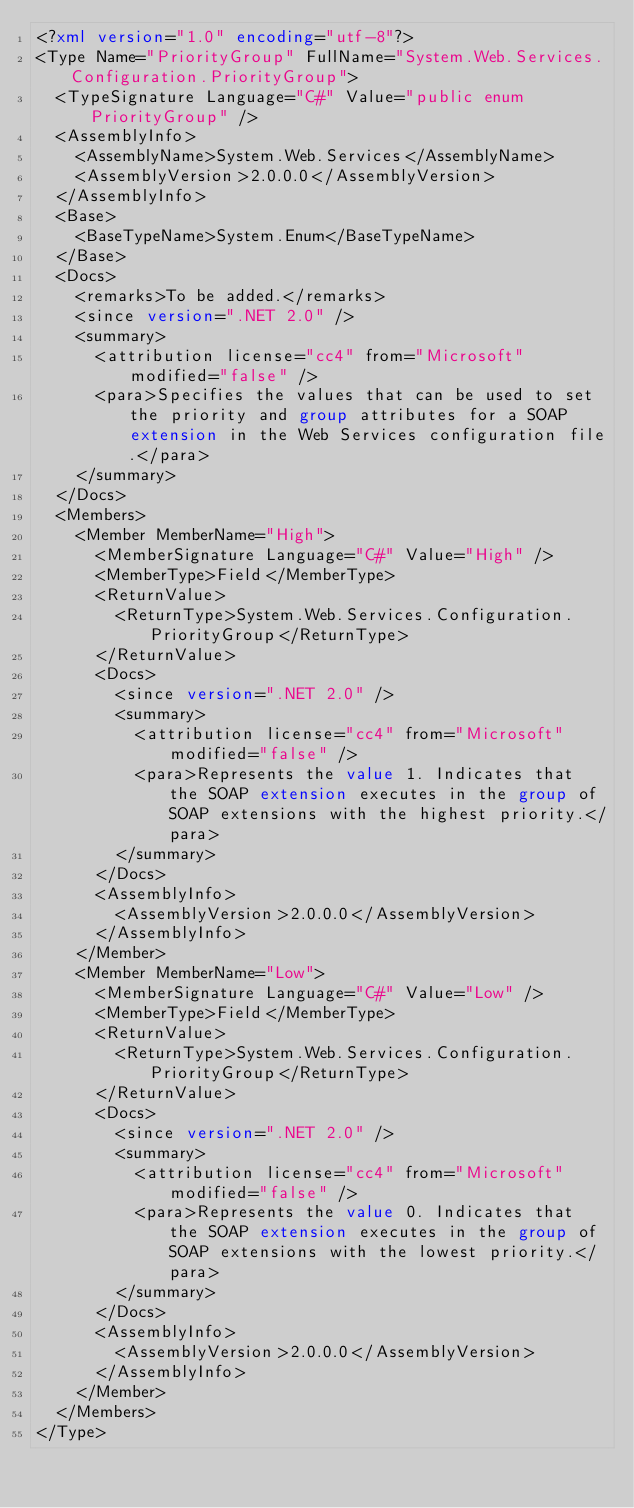Convert code to text. <code><loc_0><loc_0><loc_500><loc_500><_XML_><?xml version="1.0" encoding="utf-8"?>
<Type Name="PriorityGroup" FullName="System.Web.Services.Configuration.PriorityGroup">
  <TypeSignature Language="C#" Value="public enum PriorityGroup" />
  <AssemblyInfo>
    <AssemblyName>System.Web.Services</AssemblyName>
    <AssemblyVersion>2.0.0.0</AssemblyVersion>
  </AssemblyInfo>
  <Base>
    <BaseTypeName>System.Enum</BaseTypeName>
  </Base>
  <Docs>
    <remarks>To be added.</remarks>
    <since version=".NET 2.0" />
    <summary>
      <attribution license="cc4" from="Microsoft" modified="false" />
      <para>Specifies the values that can be used to set the priority and group attributes for a SOAP extension in the Web Services configuration file.</para>
    </summary>
  </Docs>
  <Members>
    <Member MemberName="High">
      <MemberSignature Language="C#" Value="High" />
      <MemberType>Field</MemberType>
      <ReturnValue>
        <ReturnType>System.Web.Services.Configuration.PriorityGroup</ReturnType>
      </ReturnValue>
      <Docs>
        <since version=".NET 2.0" />
        <summary>
          <attribution license="cc4" from="Microsoft" modified="false" />
          <para>Represents the value 1. Indicates that the SOAP extension executes in the group of SOAP extensions with the highest priority.</para>
        </summary>
      </Docs>
      <AssemblyInfo>
        <AssemblyVersion>2.0.0.0</AssemblyVersion>
      </AssemblyInfo>
    </Member>
    <Member MemberName="Low">
      <MemberSignature Language="C#" Value="Low" />
      <MemberType>Field</MemberType>
      <ReturnValue>
        <ReturnType>System.Web.Services.Configuration.PriorityGroup</ReturnType>
      </ReturnValue>
      <Docs>
        <since version=".NET 2.0" />
        <summary>
          <attribution license="cc4" from="Microsoft" modified="false" />
          <para>Represents the value 0. Indicates that the SOAP extension executes in the group of SOAP extensions with the lowest priority.</para>
        </summary>
      </Docs>
      <AssemblyInfo>
        <AssemblyVersion>2.0.0.0</AssemblyVersion>
      </AssemblyInfo>
    </Member>
  </Members>
</Type></code> 